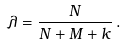<formula> <loc_0><loc_0><loc_500><loc_500>\lambda = \frac { N } { N + M + k } \, .</formula> 